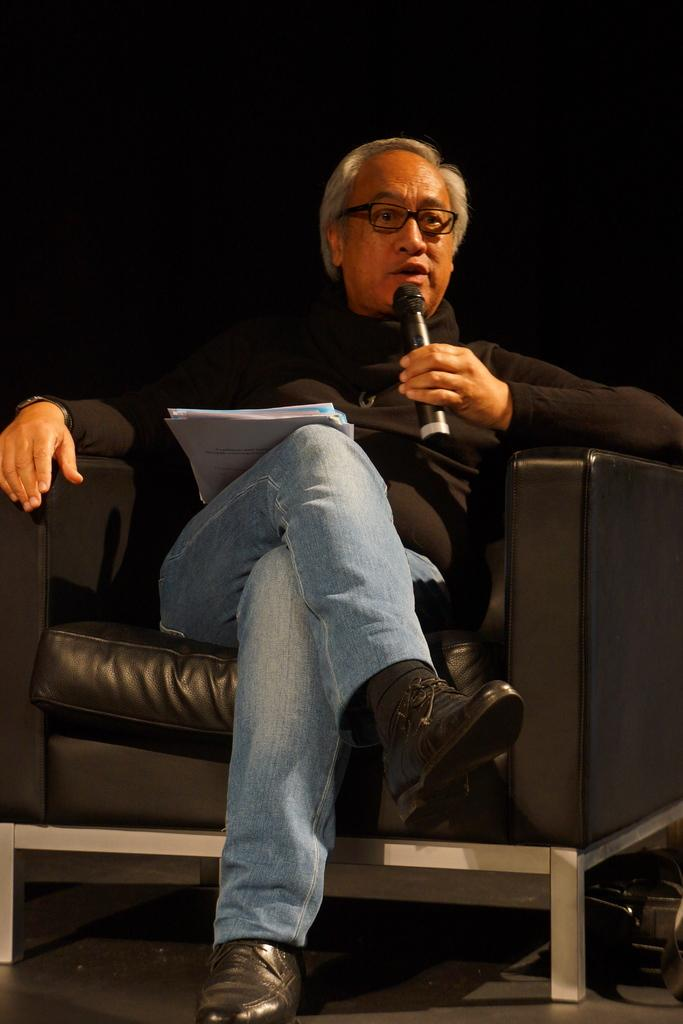What is the person in the image doing? The person is sitting on a chair and talking. What objects is the person holding? The person is holding a microphone and papers. What is the person wearing? The person is wearing a black t-shirt and glasses. Are there any cobwebs visible in the image? There is no mention of cobwebs in the provided facts, so we cannot determine if any are present in the image. 